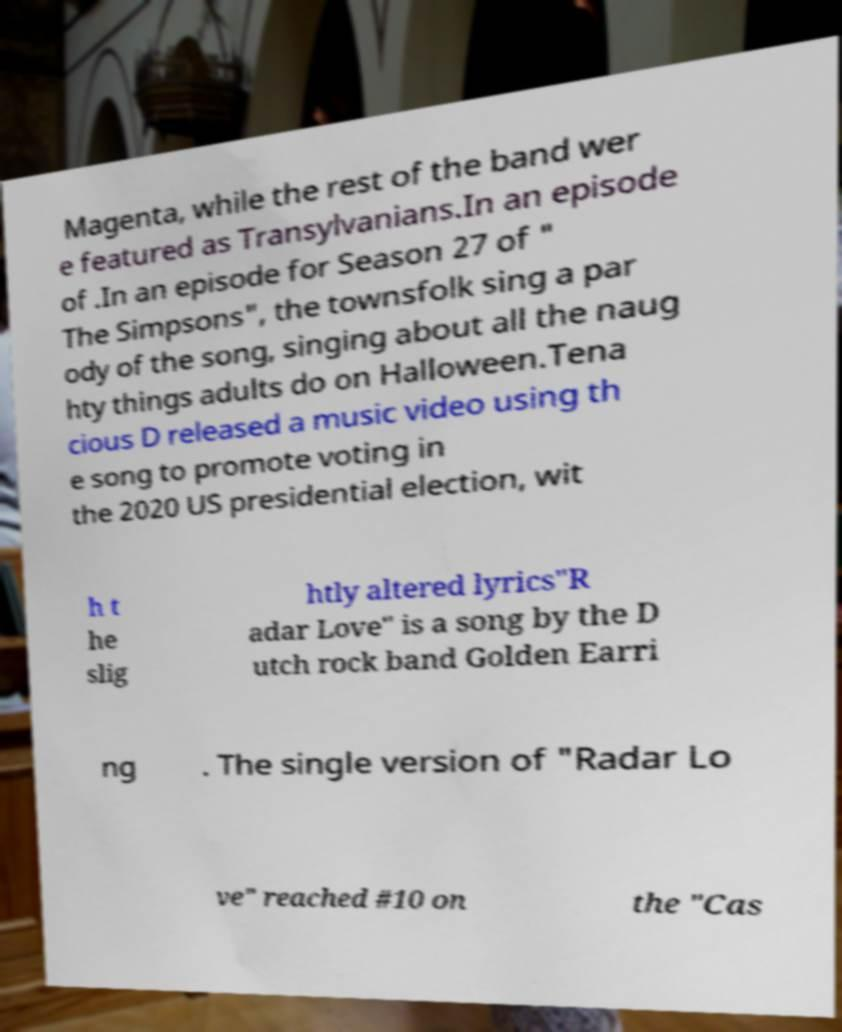For documentation purposes, I need the text within this image transcribed. Could you provide that? Magenta, while the rest of the band wer e featured as Transylvanians.In an episode of .In an episode for Season 27 of " The Simpsons", the townsfolk sing a par ody of the song, singing about all the naug hty things adults do on Halloween.Tena cious D released a music video using th e song to promote voting in the 2020 US presidential election, wit h t he slig htly altered lyrics"R adar Love" is a song by the D utch rock band Golden Earri ng . The single version of "Radar Lo ve" reached #10 on the "Cas 